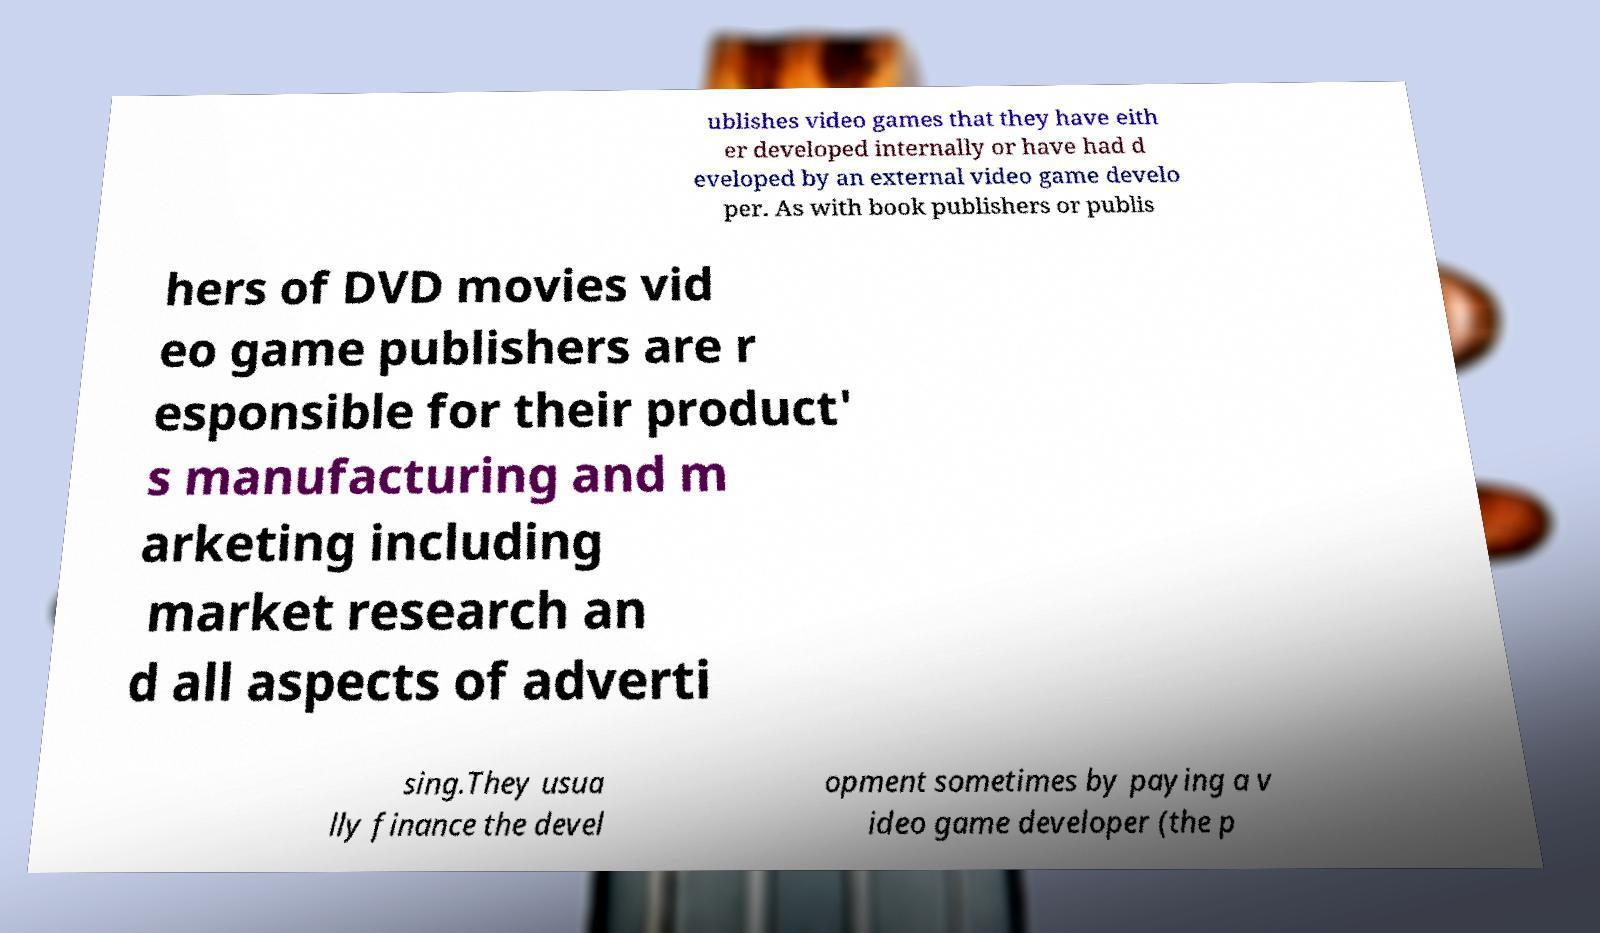Can you accurately transcribe the text from the provided image for me? ublishes video games that they have eith er developed internally or have had d eveloped by an external video game develo per. As with book publishers or publis hers of DVD movies vid eo game publishers are r esponsible for their product' s manufacturing and m arketing including market research an d all aspects of adverti sing.They usua lly finance the devel opment sometimes by paying a v ideo game developer (the p 